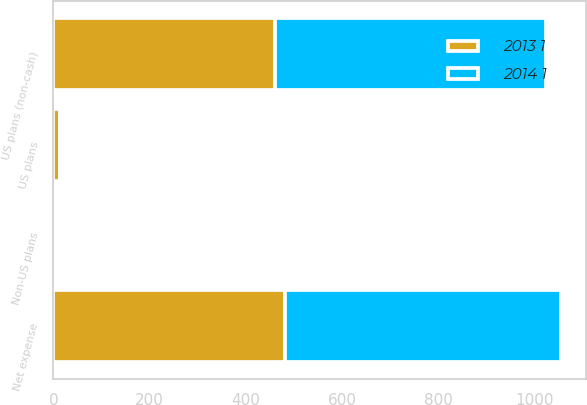Convert chart. <chart><loc_0><loc_0><loc_500><loc_500><stacked_bar_chart><ecel><fcel>US plans (non-cash)<fcel>Non-US plans<fcel>US plans<fcel>Net expense<nl><fcel>2013 1<fcel>461<fcel>5<fcel>13<fcel>481<nl><fcel>2014 1<fcel>561<fcel>5<fcel>5<fcel>573<nl></chart> 